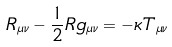<formula> <loc_0><loc_0><loc_500><loc_500>R _ { \mu \nu } - \frac { 1 } { 2 } R g _ { \mu \nu } = - \kappa T _ { \mu \nu }</formula> 